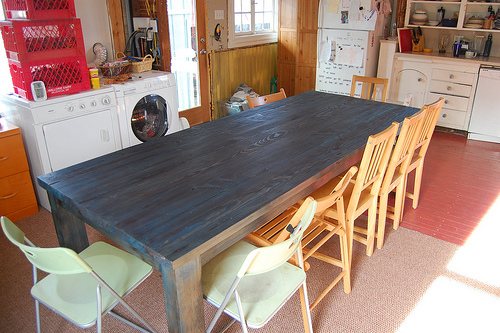<image>
Can you confirm if the chair is behind the table? Yes. From this viewpoint, the chair is positioned behind the table, with the table partially or fully occluding the chair. 